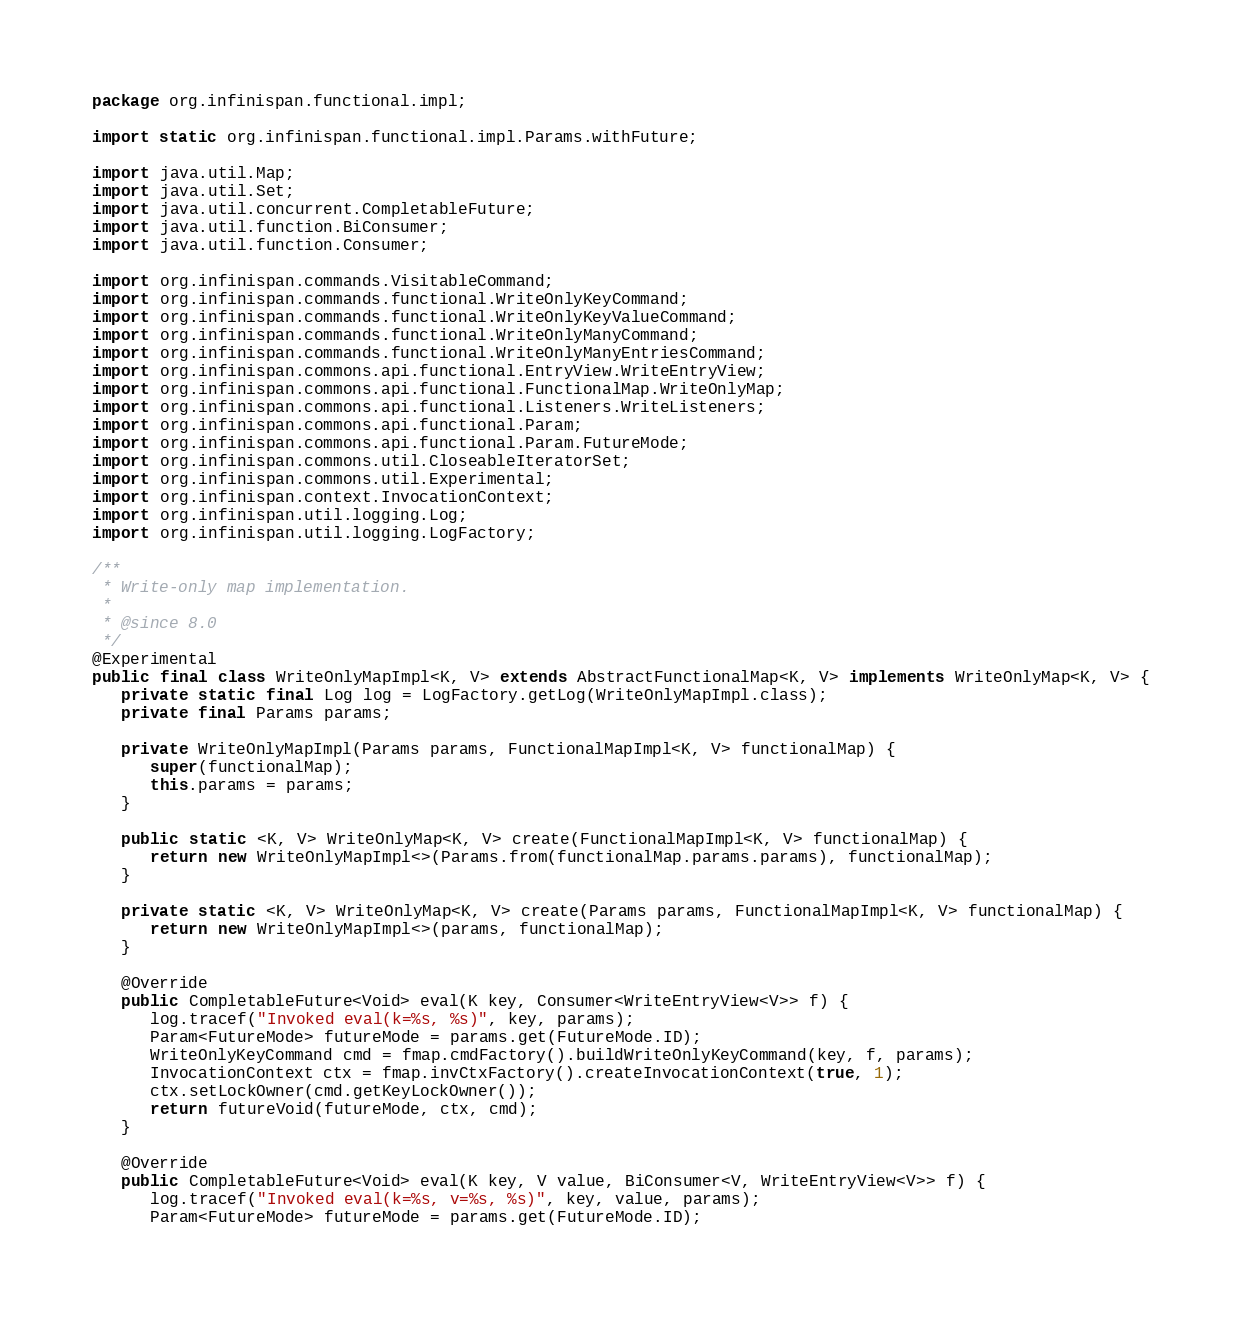<code> <loc_0><loc_0><loc_500><loc_500><_Java_>package org.infinispan.functional.impl;

import static org.infinispan.functional.impl.Params.withFuture;

import java.util.Map;
import java.util.Set;
import java.util.concurrent.CompletableFuture;
import java.util.function.BiConsumer;
import java.util.function.Consumer;

import org.infinispan.commands.VisitableCommand;
import org.infinispan.commands.functional.WriteOnlyKeyCommand;
import org.infinispan.commands.functional.WriteOnlyKeyValueCommand;
import org.infinispan.commands.functional.WriteOnlyManyCommand;
import org.infinispan.commands.functional.WriteOnlyManyEntriesCommand;
import org.infinispan.commons.api.functional.EntryView.WriteEntryView;
import org.infinispan.commons.api.functional.FunctionalMap.WriteOnlyMap;
import org.infinispan.commons.api.functional.Listeners.WriteListeners;
import org.infinispan.commons.api.functional.Param;
import org.infinispan.commons.api.functional.Param.FutureMode;
import org.infinispan.commons.util.CloseableIteratorSet;
import org.infinispan.commons.util.Experimental;
import org.infinispan.context.InvocationContext;
import org.infinispan.util.logging.Log;
import org.infinispan.util.logging.LogFactory;

/**
 * Write-only map implementation.
 *
 * @since 8.0
 */
@Experimental
public final class WriteOnlyMapImpl<K, V> extends AbstractFunctionalMap<K, V> implements WriteOnlyMap<K, V> {
   private static final Log log = LogFactory.getLog(WriteOnlyMapImpl.class);
   private final Params params;

   private WriteOnlyMapImpl(Params params, FunctionalMapImpl<K, V> functionalMap) {
      super(functionalMap);
      this.params = params;
   }

   public static <K, V> WriteOnlyMap<K, V> create(FunctionalMapImpl<K, V> functionalMap) {
      return new WriteOnlyMapImpl<>(Params.from(functionalMap.params.params), functionalMap);
   }

   private static <K, V> WriteOnlyMap<K, V> create(Params params, FunctionalMapImpl<K, V> functionalMap) {
      return new WriteOnlyMapImpl<>(params, functionalMap);
   }

   @Override
   public CompletableFuture<Void> eval(K key, Consumer<WriteEntryView<V>> f) {
      log.tracef("Invoked eval(k=%s, %s)", key, params);
      Param<FutureMode> futureMode = params.get(FutureMode.ID);
      WriteOnlyKeyCommand cmd = fmap.cmdFactory().buildWriteOnlyKeyCommand(key, f, params);
      InvocationContext ctx = fmap.invCtxFactory().createInvocationContext(true, 1);
      ctx.setLockOwner(cmd.getKeyLockOwner());
      return futureVoid(futureMode, ctx, cmd);
   }

   @Override
   public CompletableFuture<Void> eval(K key, V value, BiConsumer<V, WriteEntryView<V>> f) {
      log.tracef("Invoked eval(k=%s, v=%s, %s)", key, value, params);
      Param<FutureMode> futureMode = params.get(FutureMode.ID);</code> 